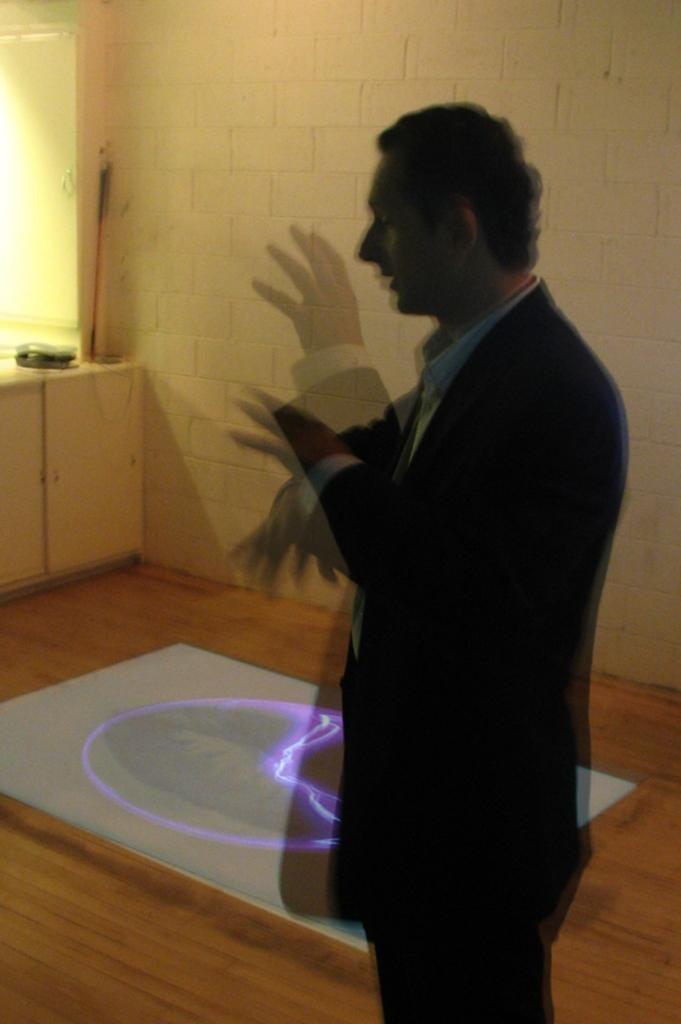What is the main subject in the image? There is a person standing in the image. What type of background can be seen in the image? There is a brick wall in the image. What reason does the canvas have for being present in the image? There is no canvas present in the image. How old is the boy in the image? There is no boy present in the image, only a person. 